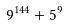Convert formula to latex. <formula><loc_0><loc_0><loc_500><loc_500>9 ^ { 1 4 4 } + 5 ^ { 9 }</formula> 